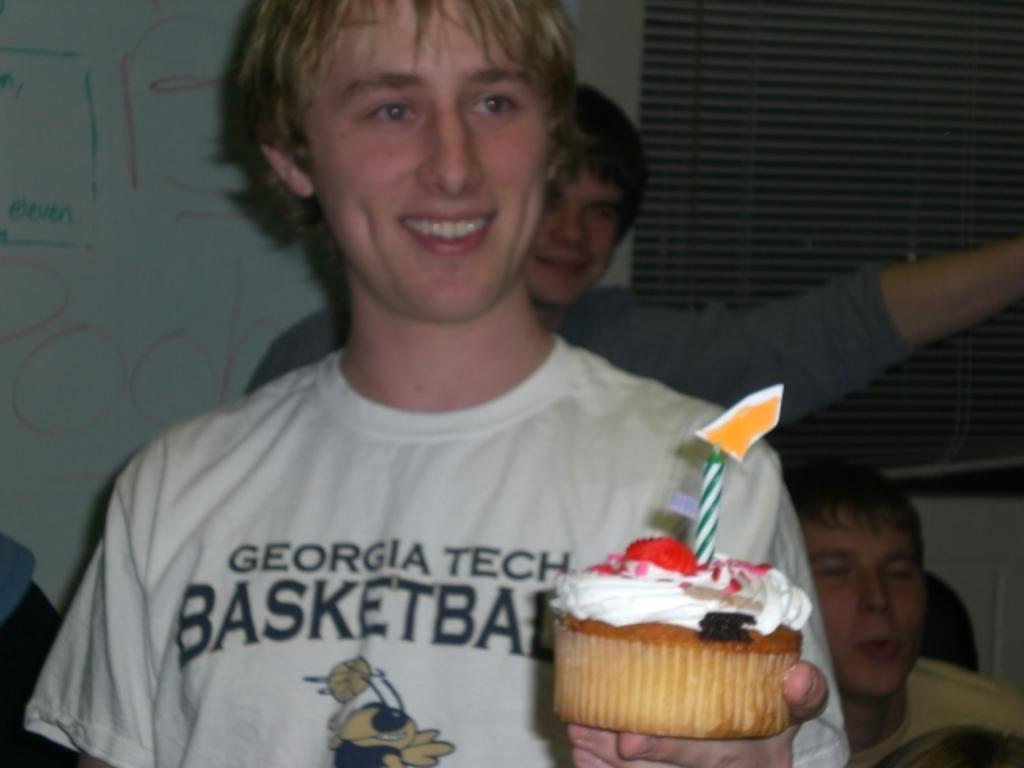How many people are in the image? There are three persons in the image. What is the person wearing a white shirt doing? The person in the white shirt is holding a cake. What is the facial expression of the person in the white shirt? The person in the white shirt has a smiling face. What type of vest is the person wearing in the image? There is no mention of a vest in the image, so it cannot be determined if the person is wearing one. 